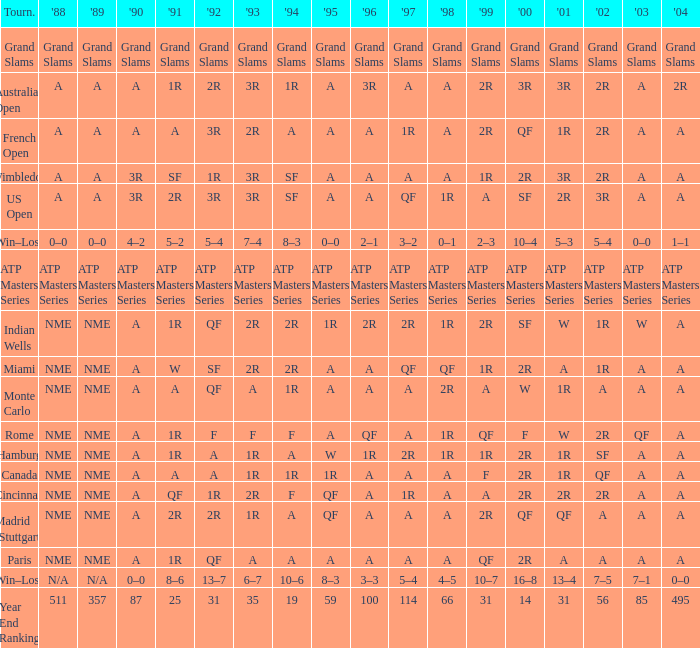What shows for 1988 when 1994 shows 10–6? N/A. 